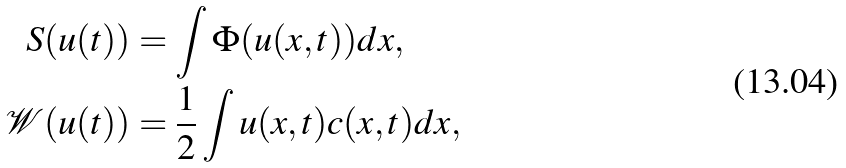<formula> <loc_0><loc_0><loc_500><loc_500>S ( u ( t ) ) & = \int \Phi ( u ( x , t ) ) d x , \\ \mathcal { W } ( u ( t ) ) & = \frac { 1 } { 2 } \int u ( x , t ) c ( x , t ) d x ,</formula> 